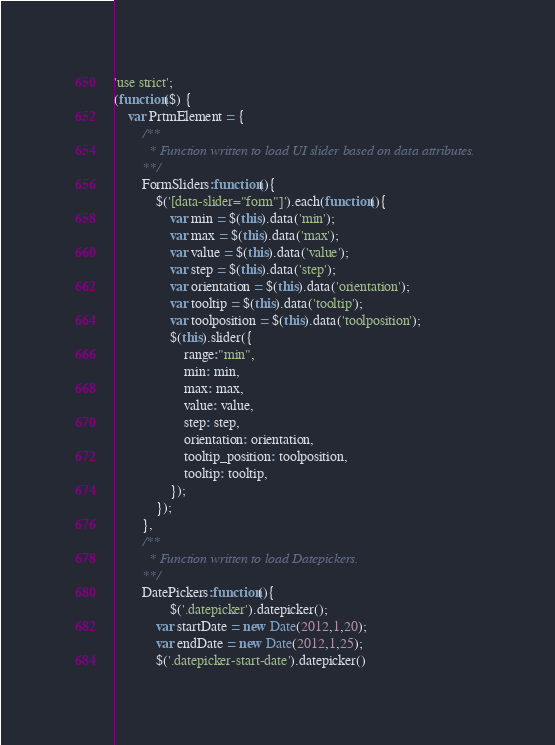<code> <loc_0><loc_0><loc_500><loc_500><_JavaScript_>'use strict';
(function($) {
	var PrtmElement = {
		/**
		  * Function written to load UI slider based on data attributes.
		**/
		FormSliders:function(){
			$('[data-slider="form"]').each(function(){
				var min = $(this).data('min');
				var max = $(this).data('max');
				var value = $(this).data('value');
				var step = $(this).data('step');
				var orientation = $(this).data('orientation');
				var tooltip = $(this).data('tooltip');
				var toolposition = $(this).data('toolposition');
			    $(this).slider({
			    	range:"min",
			        min: min,
			        max: max,
			        value: value,
			        step: step,
			        orientation: orientation,
			        tooltip_position: toolposition,
			        tooltip: tooltip,
			    });
			});
		},
		/**
		  * Function written to load Datepickers.
		**/
		DatePickers:function(){
				$('.datepicker').datepicker();
		    var startDate = new Date(2012,1,20);
		    var endDate = new Date(2012,1,25);
		    $('.datepicker-start-date').datepicker()</code> 